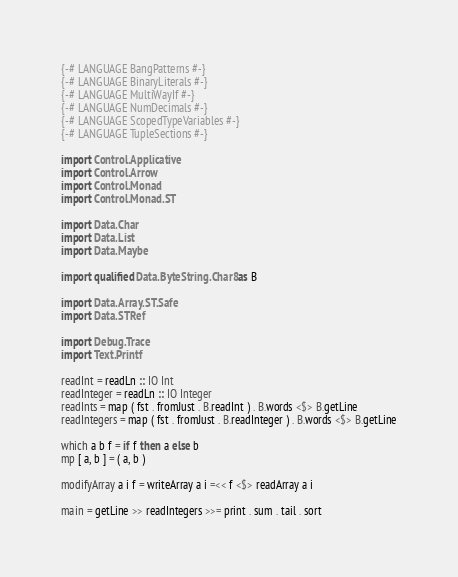<code> <loc_0><loc_0><loc_500><loc_500><_Haskell_>{-# LANGUAGE BangPatterns #-}
{-# LANGUAGE BinaryLiterals #-}
{-# LANGUAGE MultiWayIf #-}
{-# LANGUAGE NumDecimals #-}
{-# LANGUAGE ScopedTypeVariables #-}
{-# LANGUAGE TupleSections #-}

import Control.Applicative
import Control.Arrow
import Control.Monad
import Control.Monad.ST

import Data.Char
import Data.List
import Data.Maybe

import qualified Data.ByteString.Char8 as B

import Data.Array.ST.Safe
import Data.STRef

import Debug.Trace
import Text.Printf

readInt = readLn :: IO Int
readInteger = readLn :: IO Integer
readInts = map ( fst . fromJust . B.readInt ) . B.words <$> B.getLine
readIntegers = map ( fst . fromJust . B.readInteger ) . B.words <$> B.getLine

which a b f = if f then a else b
mp [ a, b ] = ( a, b )

modifyArray a i f = writeArray a i =<< f <$> readArray a i

main = getLine >> readIntegers >>= print . sum . tail . sort</code> 